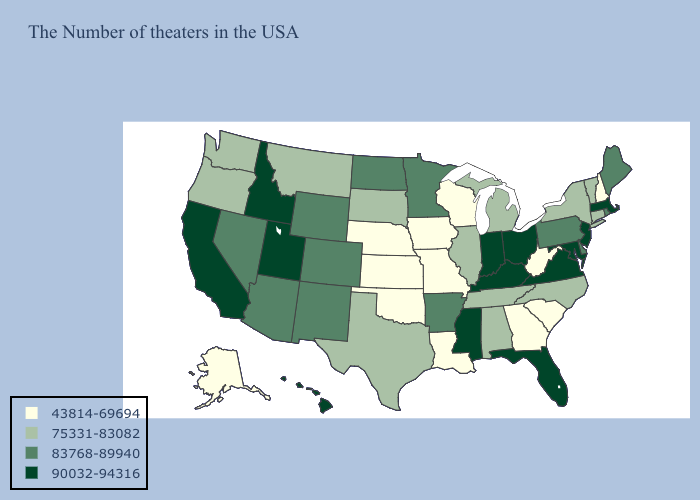Does Alabama have a lower value than Kentucky?
Be succinct. Yes. What is the lowest value in the USA?
Quick response, please. 43814-69694. What is the highest value in the West ?
Short answer required. 90032-94316. What is the lowest value in the South?
Write a very short answer. 43814-69694. Which states hav the highest value in the Northeast?
Answer briefly. Massachusetts, New Jersey. Does Arizona have a lower value than New Mexico?
Keep it brief. No. Name the states that have a value in the range 83768-89940?
Keep it brief. Maine, Rhode Island, Delaware, Pennsylvania, Arkansas, Minnesota, North Dakota, Wyoming, Colorado, New Mexico, Arizona, Nevada. Among the states that border Tennessee , does Missouri have the lowest value?
Short answer required. Yes. Among the states that border Arkansas , does Missouri have the highest value?
Short answer required. No. What is the value of Indiana?
Concise answer only. 90032-94316. What is the value of Michigan?
Answer briefly. 75331-83082. Does New York have the lowest value in the Northeast?
Be succinct. No. What is the lowest value in the USA?
Answer briefly. 43814-69694. Among the states that border Minnesota , which have the highest value?
Keep it brief. North Dakota. Among the states that border Florida , which have the lowest value?
Write a very short answer. Georgia. 